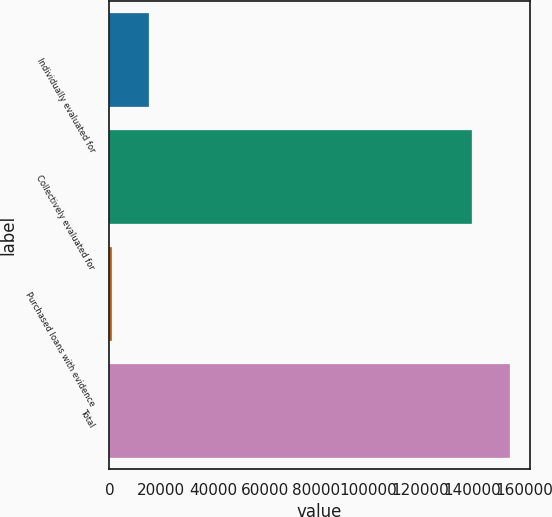<chart> <loc_0><loc_0><loc_500><loc_500><bar_chart><fcel>Individually evaluated for<fcel>Collectively evaluated for<fcel>Purchased loans with evidence<fcel>Total<nl><fcel>15303.7<fcel>140090<fcel>892<fcel>154502<nl></chart> 